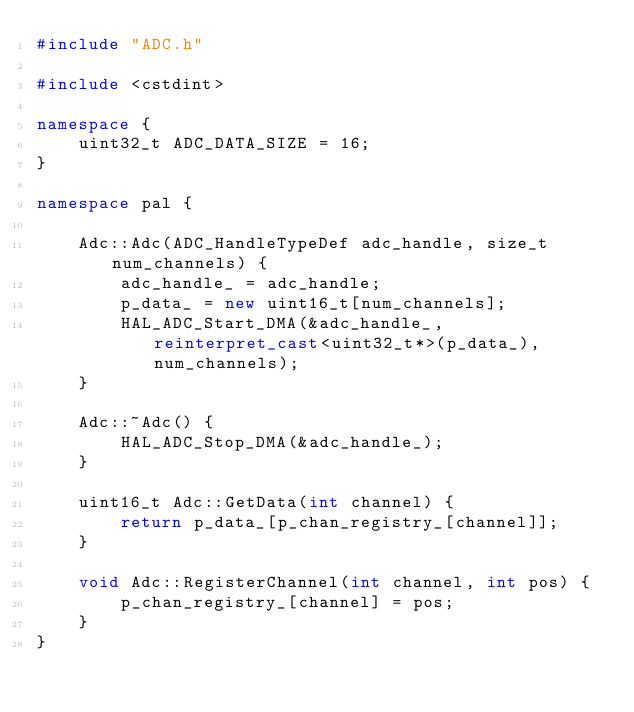Convert code to text. <code><loc_0><loc_0><loc_500><loc_500><_C++_>#include "ADC.h"

#include <cstdint>

namespace {
    uint32_t ADC_DATA_SIZE = 16;
}

namespace pal {
    
    Adc::Adc(ADC_HandleTypeDef adc_handle, size_t num_channels) {
        adc_handle_ = adc_handle;
        p_data_ = new uint16_t[num_channels];
        HAL_ADC_Start_DMA(&adc_handle_, reinterpret_cast<uint32_t*>(p_data_), num_channels);
    }
 
    Adc::~Adc() {
        HAL_ADC_Stop_DMA(&adc_handle_);
    }
 
    uint16_t Adc::GetData(int channel) {
        return p_data_[p_chan_registry_[channel]];
    }
    
    void Adc::RegisterChannel(int channel, int pos) {
        p_chan_registry_[channel] = pos;
    }
}</code> 